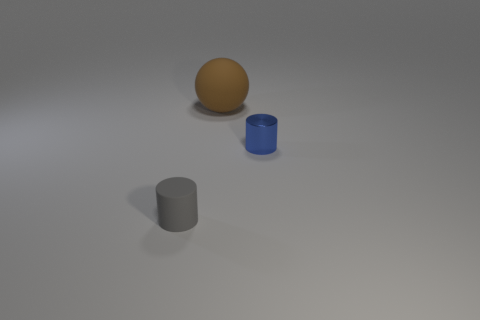Add 1 cylinders. How many objects exist? 4 Subtract all spheres. How many objects are left? 2 Subtract all brown things. Subtract all brown spheres. How many objects are left? 1 Add 1 large brown spheres. How many large brown spheres are left? 2 Add 1 large purple matte blocks. How many large purple matte blocks exist? 1 Subtract 1 blue cylinders. How many objects are left? 2 